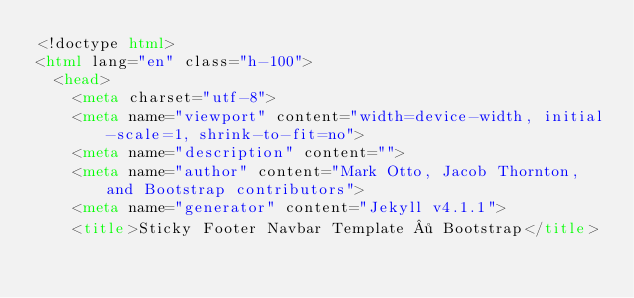<code> <loc_0><loc_0><loc_500><loc_500><_HTML_><!doctype html>
<html lang="en" class="h-100">
  <head>
    <meta charset="utf-8">
    <meta name="viewport" content="width=device-width, initial-scale=1, shrink-to-fit=no">
    <meta name="description" content="">
    <meta name="author" content="Mark Otto, Jacob Thornton, and Bootstrap contributors">
    <meta name="generator" content="Jekyll v4.1.1">
    <title>Sticky Footer Navbar Template · Bootstrap</title>
</code> 